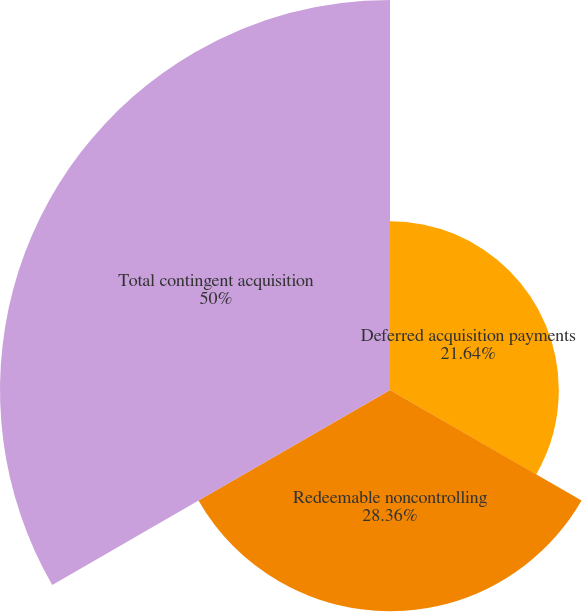Convert chart to OTSL. <chart><loc_0><loc_0><loc_500><loc_500><pie_chart><fcel>Deferred acquisition payments<fcel>Redeemable noncontrolling<fcel>Total contingent acquisition<nl><fcel>21.64%<fcel>28.36%<fcel>50.0%<nl></chart> 